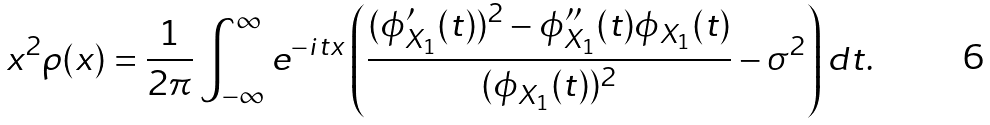<formula> <loc_0><loc_0><loc_500><loc_500>x ^ { 2 } \rho ( x ) = \frac { 1 } { 2 \pi } \int _ { - \infty } ^ { \infty } e ^ { - i t x } \left ( \frac { ( \phi _ { X _ { 1 } } ^ { \prime } ( t ) ) ^ { 2 } - \phi _ { X _ { 1 } } ^ { \prime \prime } ( t ) \phi _ { X _ { 1 } } ( t ) } { ( \phi _ { X _ { 1 } } ( t ) ) ^ { 2 } } - \sigma ^ { 2 } \right ) d t .</formula> 